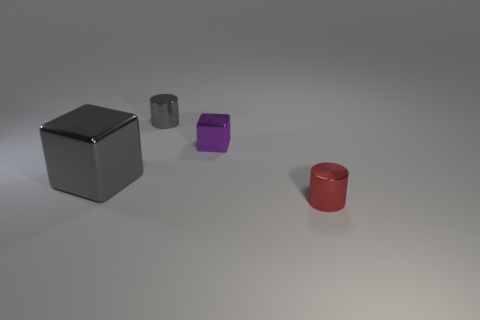How does the lighting affect the appearance of the objects? The soft, diffused lighting creates subtle shadows and gives the objects a smooth appearance. It enhances the metallic texture of the objects and provides a clear view of their shapes and colors without harsh glare or overly dramatic contrasts. 